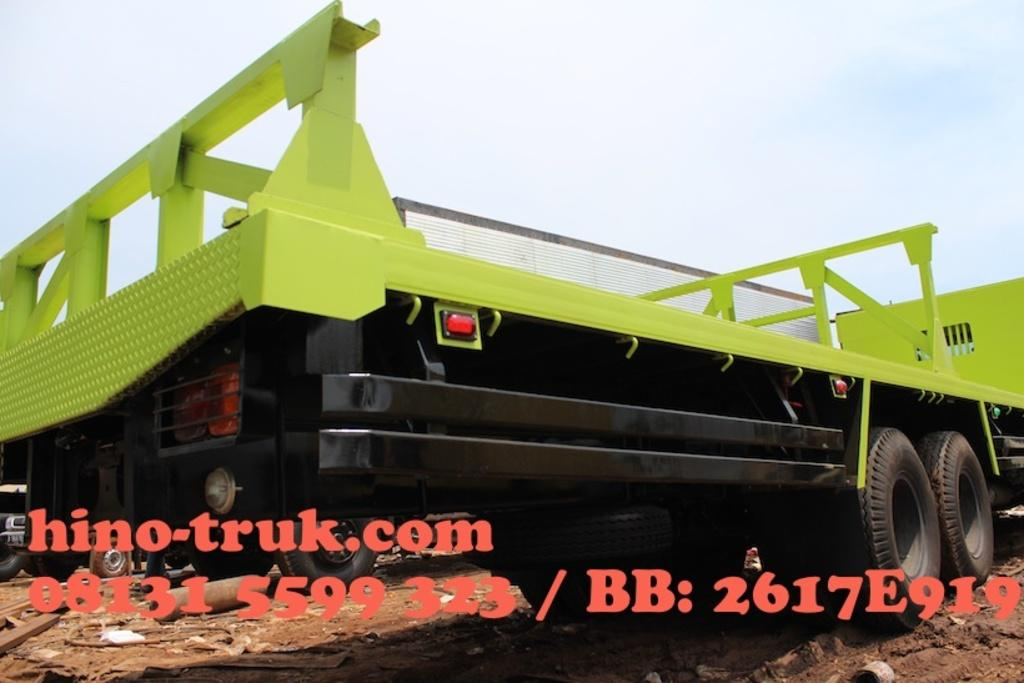What is located on the ground in the image? There are vehicles on the ground in the image. What can be seen in the background of the image? The sky is visible in the background of the image. Is there any text or numbers present in the image? Yes, there is text and a number at the bottom of the image. What type of teeth can be seen in the image? There are no teeth present in the image. What is the fifth vehicle in the image? The provided facts do not mention the number of vehicles or their specific types, so it is impossible to determine the fifth vehicle. 